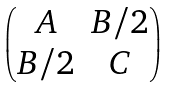<formula> <loc_0><loc_0><loc_500><loc_500>\begin{pmatrix} A & B / 2 \\ B / 2 & C \end{pmatrix}</formula> 